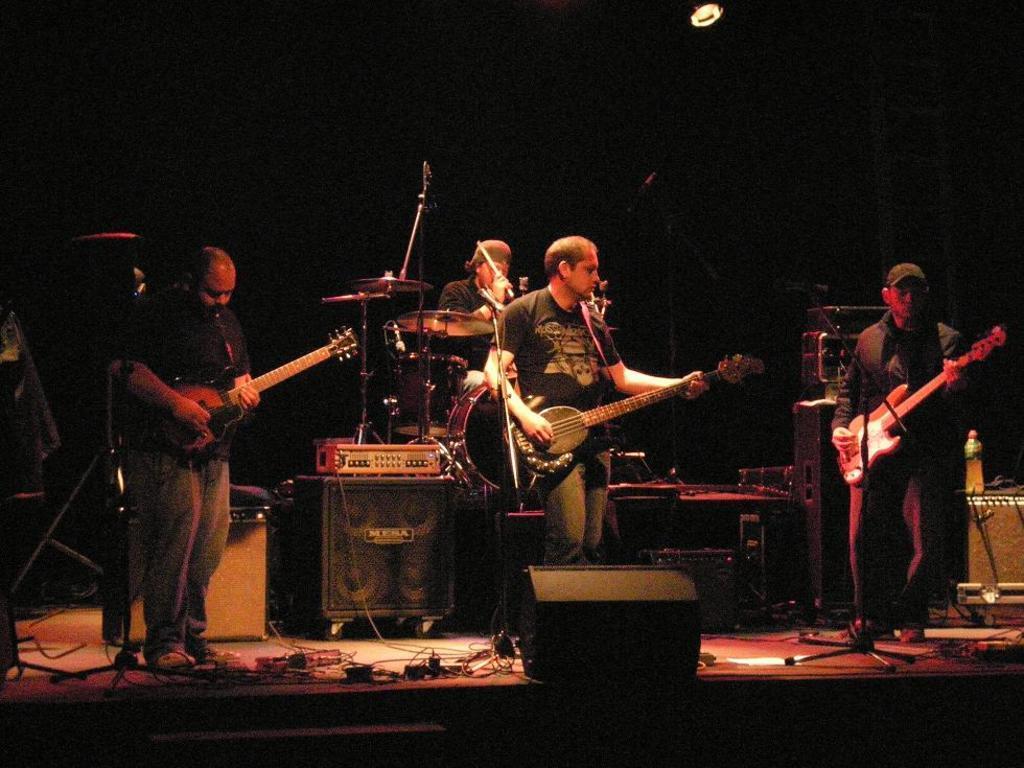Could you give a brief overview of what you see in this image? In this image i can see few persons standing on the stage and holding guitars in their hands. In the background i can see few speakers, a musical system, few musical instruments and a person holding sticks and a light. 